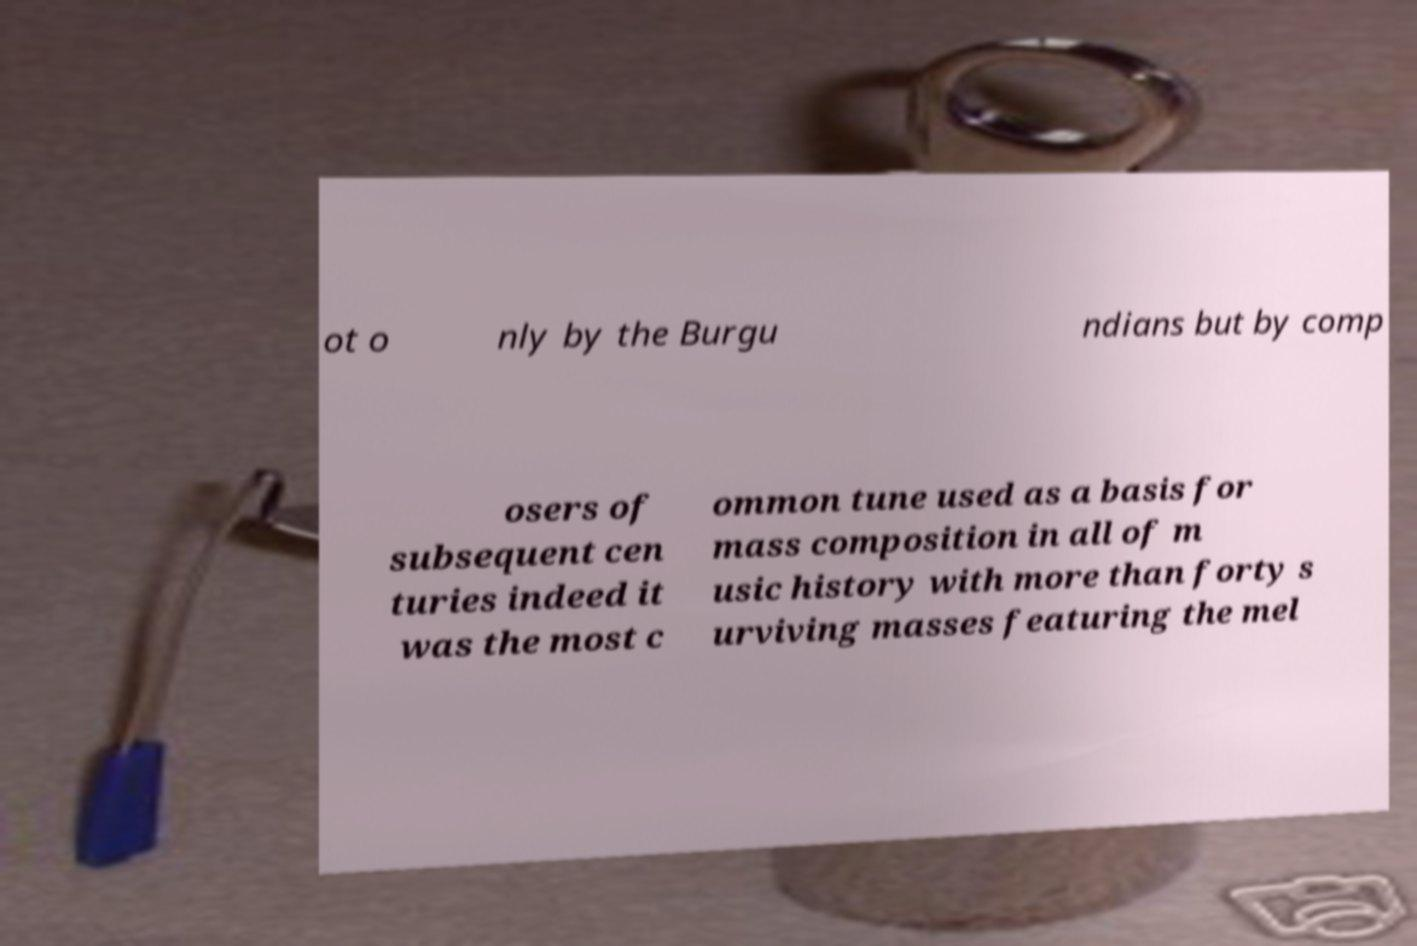There's text embedded in this image that I need extracted. Can you transcribe it verbatim? ot o nly by the Burgu ndians but by comp osers of subsequent cen turies indeed it was the most c ommon tune used as a basis for mass composition in all of m usic history with more than forty s urviving masses featuring the mel 